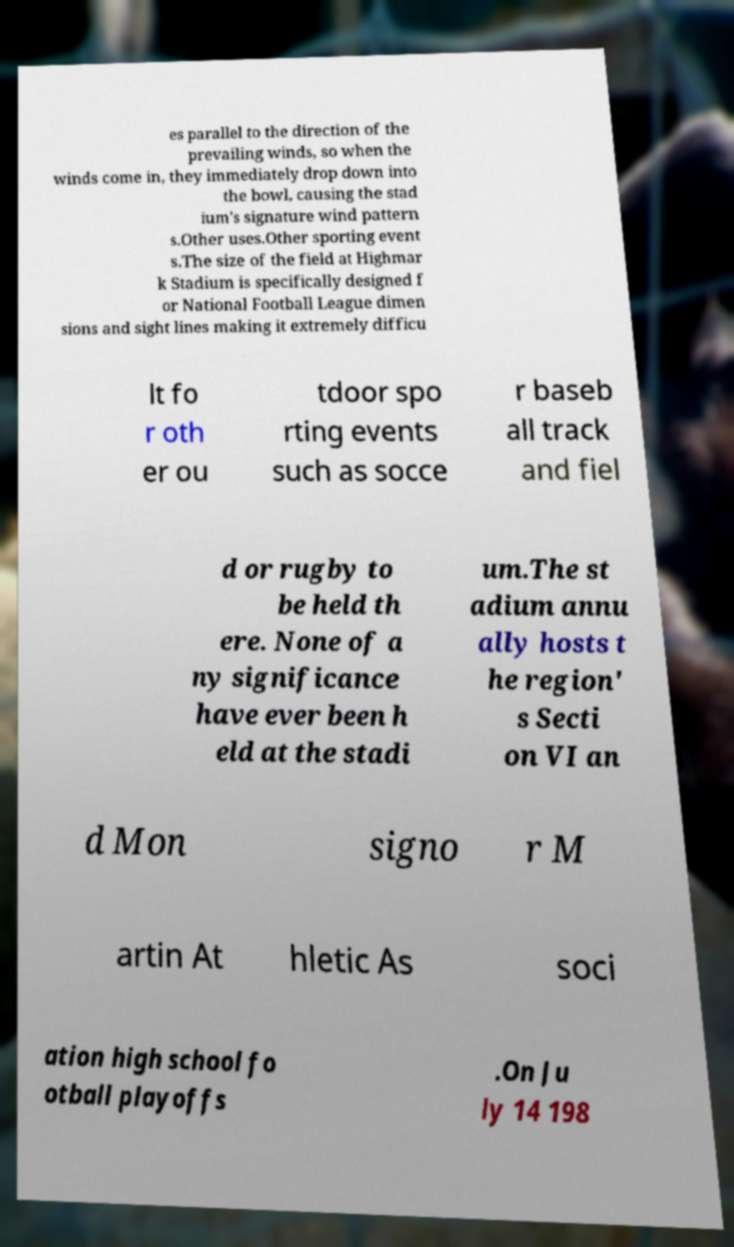Could you extract and type out the text from this image? es parallel to the direction of the prevailing winds, so when the winds come in, they immediately drop down into the bowl, causing the stad ium's signature wind pattern s.Other uses.Other sporting event s.The size of the field at Highmar k Stadium is specifically designed f or National Football League dimen sions and sight lines making it extremely difficu lt fo r oth er ou tdoor spo rting events such as socce r baseb all track and fiel d or rugby to be held th ere. None of a ny significance have ever been h eld at the stadi um.The st adium annu ally hosts t he region' s Secti on VI an d Mon signo r M artin At hletic As soci ation high school fo otball playoffs .On Ju ly 14 198 